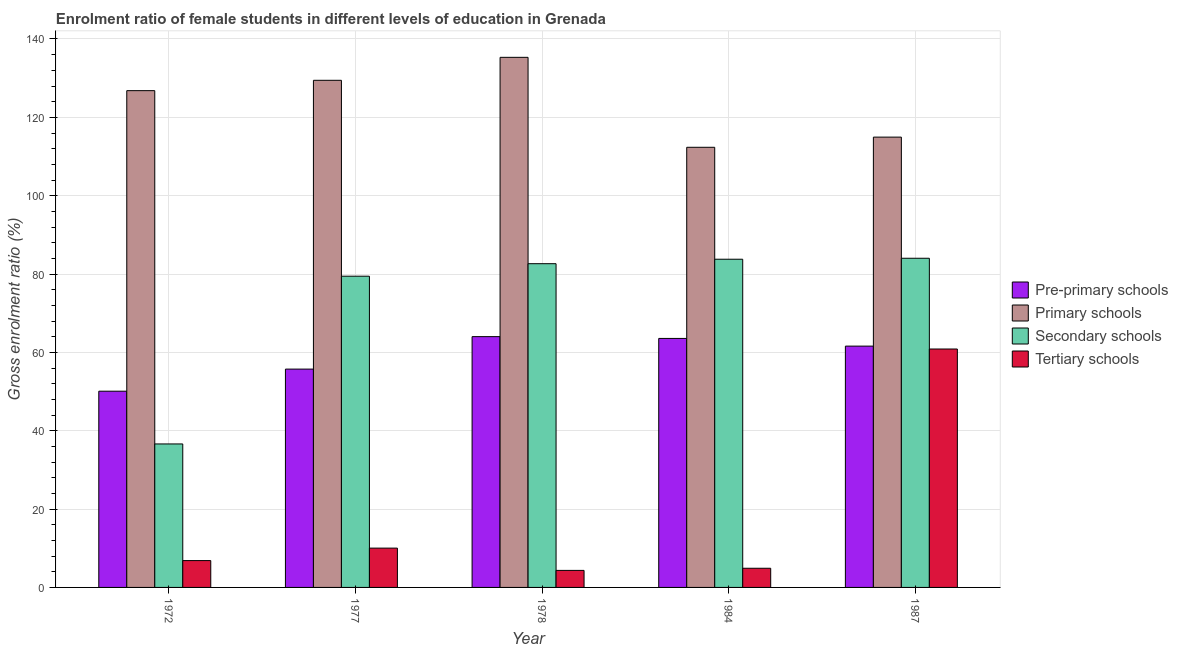Are the number of bars per tick equal to the number of legend labels?
Provide a short and direct response. Yes. Are the number of bars on each tick of the X-axis equal?
Ensure brevity in your answer.  Yes. In how many cases, is the number of bars for a given year not equal to the number of legend labels?
Offer a terse response. 0. What is the gross enrolment ratio(male) in pre-primary schools in 1972?
Provide a short and direct response. 50.09. Across all years, what is the maximum gross enrolment ratio(male) in pre-primary schools?
Provide a succinct answer. 64.02. Across all years, what is the minimum gross enrolment ratio(male) in secondary schools?
Your answer should be very brief. 36.63. In which year was the gross enrolment ratio(male) in primary schools minimum?
Offer a very short reply. 1984. What is the total gross enrolment ratio(male) in tertiary schools in the graph?
Make the answer very short. 86.99. What is the difference between the gross enrolment ratio(male) in primary schools in 1977 and that in 1987?
Give a very brief answer. 14.5. What is the difference between the gross enrolment ratio(male) in primary schools in 1978 and the gross enrolment ratio(male) in tertiary schools in 1984?
Provide a succinct answer. 22.96. What is the average gross enrolment ratio(male) in pre-primary schools per year?
Your answer should be very brief. 59. In the year 1987, what is the difference between the gross enrolment ratio(male) in pre-primary schools and gross enrolment ratio(male) in primary schools?
Offer a very short reply. 0. What is the ratio of the gross enrolment ratio(male) in pre-primary schools in 1978 to that in 1987?
Provide a short and direct response. 1.04. Is the gross enrolment ratio(male) in primary schools in 1977 less than that in 1987?
Ensure brevity in your answer.  No. Is the difference between the gross enrolment ratio(male) in tertiary schools in 1984 and 1987 greater than the difference between the gross enrolment ratio(male) in pre-primary schools in 1984 and 1987?
Ensure brevity in your answer.  No. What is the difference between the highest and the second highest gross enrolment ratio(male) in pre-primary schools?
Your answer should be very brief. 0.46. What is the difference between the highest and the lowest gross enrolment ratio(male) in tertiary schools?
Your answer should be very brief. 56.52. Is it the case that in every year, the sum of the gross enrolment ratio(male) in tertiary schools and gross enrolment ratio(male) in secondary schools is greater than the sum of gross enrolment ratio(male) in primary schools and gross enrolment ratio(male) in pre-primary schools?
Keep it short and to the point. No. What does the 4th bar from the left in 1987 represents?
Offer a very short reply. Tertiary schools. What does the 2nd bar from the right in 1984 represents?
Make the answer very short. Secondary schools. How many years are there in the graph?
Your response must be concise. 5. Does the graph contain grids?
Offer a very short reply. Yes. What is the title of the graph?
Ensure brevity in your answer.  Enrolment ratio of female students in different levels of education in Grenada. What is the Gross enrolment ratio (%) of Pre-primary schools in 1972?
Keep it short and to the point. 50.09. What is the Gross enrolment ratio (%) in Primary schools in 1972?
Provide a succinct answer. 126.81. What is the Gross enrolment ratio (%) in Secondary schools in 1972?
Your answer should be very brief. 36.63. What is the Gross enrolment ratio (%) in Tertiary schools in 1972?
Provide a succinct answer. 6.85. What is the Gross enrolment ratio (%) in Pre-primary schools in 1977?
Make the answer very short. 55.73. What is the Gross enrolment ratio (%) of Primary schools in 1977?
Your response must be concise. 129.45. What is the Gross enrolment ratio (%) of Secondary schools in 1977?
Provide a succinct answer. 79.45. What is the Gross enrolment ratio (%) of Tertiary schools in 1977?
Keep it short and to the point. 10.03. What is the Gross enrolment ratio (%) of Pre-primary schools in 1978?
Your answer should be compact. 64.02. What is the Gross enrolment ratio (%) of Primary schools in 1978?
Give a very brief answer. 135.32. What is the Gross enrolment ratio (%) in Secondary schools in 1978?
Offer a terse response. 82.64. What is the Gross enrolment ratio (%) of Tertiary schools in 1978?
Provide a short and direct response. 4.35. What is the Gross enrolment ratio (%) of Pre-primary schools in 1984?
Give a very brief answer. 63.56. What is the Gross enrolment ratio (%) in Primary schools in 1984?
Your response must be concise. 112.36. What is the Gross enrolment ratio (%) of Secondary schools in 1984?
Make the answer very short. 83.78. What is the Gross enrolment ratio (%) of Tertiary schools in 1984?
Offer a very short reply. 4.89. What is the Gross enrolment ratio (%) in Pre-primary schools in 1987?
Offer a terse response. 61.6. What is the Gross enrolment ratio (%) of Primary schools in 1987?
Offer a very short reply. 114.95. What is the Gross enrolment ratio (%) of Secondary schools in 1987?
Offer a terse response. 84.03. What is the Gross enrolment ratio (%) of Tertiary schools in 1987?
Ensure brevity in your answer.  60.86. Across all years, what is the maximum Gross enrolment ratio (%) in Pre-primary schools?
Offer a terse response. 64.02. Across all years, what is the maximum Gross enrolment ratio (%) of Primary schools?
Your answer should be very brief. 135.32. Across all years, what is the maximum Gross enrolment ratio (%) of Secondary schools?
Make the answer very short. 84.03. Across all years, what is the maximum Gross enrolment ratio (%) of Tertiary schools?
Provide a succinct answer. 60.86. Across all years, what is the minimum Gross enrolment ratio (%) in Pre-primary schools?
Your answer should be compact. 50.09. Across all years, what is the minimum Gross enrolment ratio (%) in Primary schools?
Offer a very short reply. 112.36. Across all years, what is the minimum Gross enrolment ratio (%) in Secondary schools?
Make the answer very short. 36.63. Across all years, what is the minimum Gross enrolment ratio (%) in Tertiary schools?
Your answer should be compact. 4.35. What is the total Gross enrolment ratio (%) in Pre-primary schools in the graph?
Your answer should be compact. 295.01. What is the total Gross enrolment ratio (%) in Primary schools in the graph?
Offer a terse response. 618.9. What is the total Gross enrolment ratio (%) in Secondary schools in the graph?
Give a very brief answer. 366.52. What is the total Gross enrolment ratio (%) of Tertiary schools in the graph?
Ensure brevity in your answer.  86.99. What is the difference between the Gross enrolment ratio (%) in Pre-primary schools in 1972 and that in 1977?
Your response must be concise. -5.64. What is the difference between the Gross enrolment ratio (%) in Primary schools in 1972 and that in 1977?
Offer a terse response. -2.64. What is the difference between the Gross enrolment ratio (%) in Secondary schools in 1972 and that in 1977?
Your answer should be very brief. -42.82. What is the difference between the Gross enrolment ratio (%) in Tertiary schools in 1972 and that in 1977?
Your answer should be very brief. -3.18. What is the difference between the Gross enrolment ratio (%) in Pre-primary schools in 1972 and that in 1978?
Your response must be concise. -13.93. What is the difference between the Gross enrolment ratio (%) of Primary schools in 1972 and that in 1978?
Offer a terse response. -8.51. What is the difference between the Gross enrolment ratio (%) in Secondary schools in 1972 and that in 1978?
Provide a short and direct response. -46.01. What is the difference between the Gross enrolment ratio (%) of Tertiary schools in 1972 and that in 1978?
Your answer should be very brief. 2.51. What is the difference between the Gross enrolment ratio (%) in Pre-primary schools in 1972 and that in 1984?
Your answer should be compact. -13.47. What is the difference between the Gross enrolment ratio (%) in Primary schools in 1972 and that in 1984?
Ensure brevity in your answer.  14.46. What is the difference between the Gross enrolment ratio (%) of Secondary schools in 1972 and that in 1984?
Make the answer very short. -47.15. What is the difference between the Gross enrolment ratio (%) in Tertiary schools in 1972 and that in 1984?
Your answer should be compact. 1.96. What is the difference between the Gross enrolment ratio (%) of Pre-primary schools in 1972 and that in 1987?
Provide a short and direct response. -11.51. What is the difference between the Gross enrolment ratio (%) of Primary schools in 1972 and that in 1987?
Your answer should be very brief. 11.86. What is the difference between the Gross enrolment ratio (%) in Secondary schools in 1972 and that in 1987?
Your answer should be very brief. -47.4. What is the difference between the Gross enrolment ratio (%) in Tertiary schools in 1972 and that in 1987?
Your response must be concise. -54.01. What is the difference between the Gross enrolment ratio (%) of Pre-primary schools in 1977 and that in 1978?
Your response must be concise. -8.29. What is the difference between the Gross enrolment ratio (%) of Primary schools in 1977 and that in 1978?
Your response must be concise. -5.87. What is the difference between the Gross enrolment ratio (%) of Secondary schools in 1977 and that in 1978?
Make the answer very short. -3.19. What is the difference between the Gross enrolment ratio (%) of Tertiary schools in 1977 and that in 1978?
Ensure brevity in your answer.  5.69. What is the difference between the Gross enrolment ratio (%) of Pre-primary schools in 1977 and that in 1984?
Your answer should be very brief. -7.83. What is the difference between the Gross enrolment ratio (%) in Primary schools in 1977 and that in 1984?
Offer a terse response. 17.1. What is the difference between the Gross enrolment ratio (%) of Secondary schools in 1977 and that in 1984?
Give a very brief answer. -4.33. What is the difference between the Gross enrolment ratio (%) in Tertiary schools in 1977 and that in 1984?
Your response must be concise. 5.14. What is the difference between the Gross enrolment ratio (%) in Pre-primary schools in 1977 and that in 1987?
Keep it short and to the point. -5.87. What is the difference between the Gross enrolment ratio (%) of Primary schools in 1977 and that in 1987?
Keep it short and to the point. 14.5. What is the difference between the Gross enrolment ratio (%) in Secondary schools in 1977 and that in 1987?
Offer a terse response. -4.58. What is the difference between the Gross enrolment ratio (%) in Tertiary schools in 1977 and that in 1987?
Make the answer very short. -50.83. What is the difference between the Gross enrolment ratio (%) of Pre-primary schools in 1978 and that in 1984?
Provide a succinct answer. 0.46. What is the difference between the Gross enrolment ratio (%) of Primary schools in 1978 and that in 1984?
Make the answer very short. 22.96. What is the difference between the Gross enrolment ratio (%) in Secondary schools in 1978 and that in 1984?
Provide a short and direct response. -1.14. What is the difference between the Gross enrolment ratio (%) of Tertiary schools in 1978 and that in 1984?
Provide a succinct answer. -0.55. What is the difference between the Gross enrolment ratio (%) in Pre-primary schools in 1978 and that in 1987?
Offer a very short reply. 2.42. What is the difference between the Gross enrolment ratio (%) of Primary schools in 1978 and that in 1987?
Ensure brevity in your answer.  20.37. What is the difference between the Gross enrolment ratio (%) of Secondary schools in 1978 and that in 1987?
Your response must be concise. -1.39. What is the difference between the Gross enrolment ratio (%) of Tertiary schools in 1978 and that in 1987?
Ensure brevity in your answer.  -56.52. What is the difference between the Gross enrolment ratio (%) in Pre-primary schools in 1984 and that in 1987?
Give a very brief answer. 1.96. What is the difference between the Gross enrolment ratio (%) in Primary schools in 1984 and that in 1987?
Offer a terse response. -2.6. What is the difference between the Gross enrolment ratio (%) in Secondary schools in 1984 and that in 1987?
Offer a terse response. -0.25. What is the difference between the Gross enrolment ratio (%) of Tertiary schools in 1984 and that in 1987?
Ensure brevity in your answer.  -55.97. What is the difference between the Gross enrolment ratio (%) of Pre-primary schools in 1972 and the Gross enrolment ratio (%) of Primary schools in 1977?
Make the answer very short. -79.36. What is the difference between the Gross enrolment ratio (%) in Pre-primary schools in 1972 and the Gross enrolment ratio (%) in Secondary schools in 1977?
Offer a very short reply. -29.35. What is the difference between the Gross enrolment ratio (%) in Pre-primary schools in 1972 and the Gross enrolment ratio (%) in Tertiary schools in 1977?
Ensure brevity in your answer.  40.06. What is the difference between the Gross enrolment ratio (%) of Primary schools in 1972 and the Gross enrolment ratio (%) of Secondary schools in 1977?
Your answer should be compact. 47.36. What is the difference between the Gross enrolment ratio (%) of Primary schools in 1972 and the Gross enrolment ratio (%) of Tertiary schools in 1977?
Your answer should be very brief. 116.78. What is the difference between the Gross enrolment ratio (%) in Secondary schools in 1972 and the Gross enrolment ratio (%) in Tertiary schools in 1977?
Provide a succinct answer. 26.59. What is the difference between the Gross enrolment ratio (%) of Pre-primary schools in 1972 and the Gross enrolment ratio (%) of Primary schools in 1978?
Keep it short and to the point. -85.23. What is the difference between the Gross enrolment ratio (%) of Pre-primary schools in 1972 and the Gross enrolment ratio (%) of Secondary schools in 1978?
Provide a succinct answer. -32.54. What is the difference between the Gross enrolment ratio (%) in Pre-primary schools in 1972 and the Gross enrolment ratio (%) in Tertiary schools in 1978?
Ensure brevity in your answer.  45.75. What is the difference between the Gross enrolment ratio (%) in Primary schools in 1972 and the Gross enrolment ratio (%) in Secondary schools in 1978?
Offer a very short reply. 44.17. What is the difference between the Gross enrolment ratio (%) of Primary schools in 1972 and the Gross enrolment ratio (%) of Tertiary schools in 1978?
Ensure brevity in your answer.  122.47. What is the difference between the Gross enrolment ratio (%) of Secondary schools in 1972 and the Gross enrolment ratio (%) of Tertiary schools in 1978?
Provide a short and direct response. 32.28. What is the difference between the Gross enrolment ratio (%) in Pre-primary schools in 1972 and the Gross enrolment ratio (%) in Primary schools in 1984?
Offer a very short reply. -62.26. What is the difference between the Gross enrolment ratio (%) in Pre-primary schools in 1972 and the Gross enrolment ratio (%) in Secondary schools in 1984?
Your answer should be compact. -33.69. What is the difference between the Gross enrolment ratio (%) of Pre-primary schools in 1972 and the Gross enrolment ratio (%) of Tertiary schools in 1984?
Keep it short and to the point. 45.2. What is the difference between the Gross enrolment ratio (%) in Primary schools in 1972 and the Gross enrolment ratio (%) in Secondary schools in 1984?
Offer a terse response. 43.03. What is the difference between the Gross enrolment ratio (%) of Primary schools in 1972 and the Gross enrolment ratio (%) of Tertiary schools in 1984?
Keep it short and to the point. 121.92. What is the difference between the Gross enrolment ratio (%) of Secondary schools in 1972 and the Gross enrolment ratio (%) of Tertiary schools in 1984?
Offer a very short reply. 31.73. What is the difference between the Gross enrolment ratio (%) in Pre-primary schools in 1972 and the Gross enrolment ratio (%) in Primary schools in 1987?
Your answer should be compact. -64.86. What is the difference between the Gross enrolment ratio (%) in Pre-primary schools in 1972 and the Gross enrolment ratio (%) in Secondary schools in 1987?
Your answer should be very brief. -33.93. What is the difference between the Gross enrolment ratio (%) of Pre-primary schools in 1972 and the Gross enrolment ratio (%) of Tertiary schools in 1987?
Your response must be concise. -10.77. What is the difference between the Gross enrolment ratio (%) of Primary schools in 1972 and the Gross enrolment ratio (%) of Secondary schools in 1987?
Your response must be concise. 42.79. What is the difference between the Gross enrolment ratio (%) of Primary schools in 1972 and the Gross enrolment ratio (%) of Tertiary schools in 1987?
Your response must be concise. 65.95. What is the difference between the Gross enrolment ratio (%) in Secondary schools in 1972 and the Gross enrolment ratio (%) in Tertiary schools in 1987?
Provide a short and direct response. -24.24. What is the difference between the Gross enrolment ratio (%) of Pre-primary schools in 1977 and the Gross enrolment ratio (%) of Primary schools in 1978?
Keep it short and to the point. -79.59. What is the difference between the Gross enrolment ratio (%) in Pre-primary schools in 1977 and the Gross enrolment ratio (%) in Secondary schools in 1978?
Keep it short and to the point. -26.91. What is the difference between the Gross enrolment ratio (%) of Pre-primary schools in 1977 and the Gross enrolment ratio (%) of Tertiary schools in 1978?
Offer a very short reply. 51.39. What is the difference between the Gross enrolment ratio (%) of Primary schools in 1977 and the Gross enrolment ratio (%) of Secondary schools in 1978?
Provide a short and direct response. 46.82. What is the difference between the Gross enrolment ratio (%) of Primary schools in 1977 and the Gross enrolment ratio (%) of Tertiary schools in 1978?
Keep it short and to the point. 125.11. What is the difference between the Gross enrolment ratio (%) in Secondary schools in 1977 and the Gross enrolment ratio (%) in Tertiary schools in 1978?
Your answer should be very brief. 75.1. What is the difference between the Gross enrolment ratio (%) in Pre-primary schools in 1977 and the Gross enrolment ratio (%) in Primary schools in 1984?
Provide a short and direct response. -56.62. What is the difference between the Gross enrolment ratio (%) of Pre-primary schools in 1977 and the Gross enrolment ratio (%) of Secondary schools in 1984?
Offer a terse response. -28.05. What is the difference between the Gross enrolment ratio (%) of Pre-primary schools in 1977 and the Gross enrolment ratio (%) of Tertiary schools in 1984?
Ensure brevity in your answer.  50.84. What is the difference between the Gross enrolment ratio (%) in Primary schools in 1977 and the Gross enrolment ratio (%) in Secondary schools in 1984?
Ensure brevity in your answer.  45.67. What is the difference between the Gross enrolment ratio (%) in Primary schools in 1977 and the Gross enrolment ratio (%) in Tertiary schools in 1984?
Ensure brevity in your answer.  124.56. What is the difference between the Gross enrolment ratio (%) in Secondary schools in 1977 and the Gross enrolment ratio (%) in Tertiary schools in 1984?
Your response must be concise. 74.55. What is the difference between the Gross enrolment ratio (%) of Pre-primary schools in 1977 and the Gross enrolment ratio (%) of Primary schools in 1987?
Make the answer very short. -59.22. What is the difference between the Gross enrolment ratio (%) in Pre-primary schools in 1977 and the Gross enrolment ratio (%) in Secondary schools in 1987?
Offer a terse response. -28.29. What is the difference between the Gross enrolment ratio (%) of Pre-primary schools in 1977 and the Gross enrolment ratio (%) of Tertiary schools in 1987?
Provide a short and direct response. -5.13. What is the difference between the Gross enrolment ratio (%) of Primary schools in 1977 and the Gross enrolment ratio (%) of Secondary schools in 1987?
Offer a terse response. 45.43. What is the difference between the Gross enrolment ratio (%) of Primary schools in 1977 and the Gross enrolment ratio (%) of Tertiary schools in 1987?
Ensure brevity in your answer.  68.59. What is the difference between the Gross enrolment ratio (%) in Secondary schools in 1977 and the Gross enrolment ratio (%) in Tertiary schools in 1987?
Offer a terse response. 18.58. What is the difference between the Gross enrolment ratio (%) in Pre-primary schools in 1978 and the Gross enrolment ratio (%) in Primary schools in 1984?
Provide a succinct answer. -48.34. What is the difference between the Gross enrolment ratio (%) in Pre-primary schools in 1978 and the Gross enrolment ratio (%) in Secondary schools in 1984?
Provide a succinct answer. -19.76. What is the difference between the Gross enrolment ratio (%) of Pre-primary schools in 1978 and the Gross enrolment ratio (%) of Tertiary schools in 1984?
Your response must be concise. 59.13. What is the difference between the Gross enrolment ratio (%) in Primary schools in 1978 and the Gross enrolment ratio (%) in Secondary schools in 1984?
Provide a succinct answer. 51.54. What is the difference between the Gross enrolment ratio (%) in Primary schools in 1978 and the Gross enrolment ratio (%) in Tertiary schools in 1984?
Make the answer very short. 130.43. What is the difference between the Gross enrolment ratio (%) of Secondary schools in 1978 and the Gross enrolment ratio (%) of Tertiary schools in 1984?
Your answer should be compact. 77.75. What is the difference between the Gross enrolment ratio (%) of Pre-primary schools in 1978 and the Gross enrolment ratio (%) of Primary schools in 1987?
Provide a succinct answer. -50.93. What is the difference between the Gross enrolment ratio (%) of Pre-primary schools in 1978 and the Gross enrolment ratio (%) of Secondary schools in 1987?
Keep it short and to the point. -20.01. What is the difference between the Gross enrolment ratio (%) in Pre-primary schools in 1978 and the Gross enrolment ratio (%) in Tertiary schools in 1987?
Provide a short and direct response. 3.16. What is the difference between the Gross enrolment ratio (%) of Primary schools in 1978 and the Gross enrolment ratio (%) of Secondary schools in 1987?
Make the answer very short. 51.29. What is the difference between the Gross enrolment ratio (%) of Primary schools in 1978 and the Gross enrolment ratio (%) of Tertiary schools in 1987?
Your response must be concise. 74.46. What is the difference between the Gross enrolment ratio (%) in Secondary schools in 1978 and the Gross enrolment ratio (%) in Tertiary schools in 1987?
Your response must be concise. 21.77. What is the difference between the Gross enrolment ratio (%) in Pre-primary schools in 1984 and the Gross enrolment ratio (%) in Primary schools in 1987?
Your response must be concise. -51.39. What is the difference between the Gross enrolment ratio (%) of Pre-primary schools in 1984 and the Gross enrolment ratio (%) of Secondary schools in 1987?
Give a very brief answer. -20.46. What is the difference between the Gross enrolment ratio (%) in Pre-primary schools in 1984 and the Gross enrolment ratio (%) in Tertiary schools in 1987?
Provide a succinct answer. 2.7. What is the difference between the Gross enrolment ratio (%) in Primary schools in 1984 and the Gross enrolment ratio (%) in Secondary schools in 1987?
Your answer should be very brief. 28.33. What is the difference between the Gross enrolment ratio (%) in Primary schools in 1984 and the Gross enrolment ratio (%) in Tertiary schools in 1987?
Ensure brevity in your answer.  51.49. What is the difference between the Gross enrolment ratio (%) in Secondary schools in 1984 and the Gross enrolment ratio (%) in Tertiary schools in 1987?
Your response must be concise. 22.92. What is the average Gross enrolment ratio (%) in Pre-primary schools per year?
Give a very brief answer. 59. What is the average Gross enrolment ratio (%) in Primary schools per year?
Provide a short and direct response. 123.78. What is the average Gross enrolment ratio (%) of Secondary schools per year?
Your response must be concise. 73.3. What is the average Gross enrolment ratio (%) of Tertiary schools per year?
Keep it short and to the point. 17.4. In the year 1972, what is the difference between the Gross enrolment ratio (%) in Pre-primary schools and Gross enrolment ratio (%) in Primary schools?
Your answer should be compact. -76.72. In the year 1972, what is the difference between the Gross enrolment ratio (%) of Pre-primary schools and Gross enrolment ratio (%) of Secondary schools?
Your response must be concise. 13.47. In the year 1972, what is the difference between the Gross enrolment ratio (%) in Pre-primary schools and Gross enrolment ratio (%) in Tertiary schools?
Make the answer very short. 43.24. In the year 1972, what is the difference between the Gross enrolment ratio (%) in Primary schools and Gross enrolment ratio (%) in Secondary schools?
Provide a succinct answer. 90.19. In the year 1972, what is the difference between the Gross enrolment ratio (%) in Primary schools and Gross enrolment ratio (%) in Tertiary schools?
Your answer should be compact. 119.96. In the year 1972, what is the difference between the Gross enrolment ratio (%) of Secondary schools and Gross enrolment ratio (%) of Tertiary schools?
Provide a short and direct response. 29.77. In the year 1977, what is the difference between the Gross enrolment ratio (%) of Pre-primary schools and Gross enrolment ratio (%) of Primary schools?
Give a very brief answer. -73.72. In the year 1977, what is the difference between the Gross enrolment ratio (%) of Pre-primary schools and Gross enrolment ratio (%) of Secondary schools?
Your response must be concise. -23.72. In the year 1977, what is the difference between the Gross enrolment ratio (%) of Pre-primary schools and Gross enrolment ratio (%) of Tertiary schools?
Keep it short and to the point. 45.7. In the year 1977, what is the difference between the Gross enrolment ratio (%) of Primary schools and Gross enrolment ratio (%) of Secondary schools?
Your answer should be very brief. 50.01. In the year 1977, what is the difference between the Gross enrolment ratio (%) of Primary schools and Gross enrolment ratio (%) of Tertiary schools?
Offer a very short reply. 119.42. In the year 1977, what is the difference between the Gross enrolment ratio (%) of Secondary schools and Gross enrolment ratio (%) of Tertiary schools?
Keep it short and to the point. 69.41. In the year 1978, what is the difference between the Gross enrolment ratio (%) in Pre-primary schools and Gross enrolment ratio (%) in Primary schools?
Offer a terse response. -71.3. In the year 1978, what is the difference between the Gross enrolment ratio (%) of Pre-primary schools and Gross enrolment ratio (%) of Secondary schools?
Your answer should be very brief. -18.62. In the year 1978, what is the difference between the Gross enrolment ratio (%) in Pre-primary schools and Gross enrolment ratio (%) in Tertiary schools?
Keep it short and to the point. 59.67. In the year 1978, what is the difference between the Gross enrolment ratio (%) of Primary schools and Gross enrolment ratio (%) of Secondary schools?
Your response must be concise. 52.68. In the year 1978, what is the difference between the Gross enrolment ratio (%) of Primary schools and Gross enrolment ratio (%) of Tertiary schools?
Provide a short and direct response. 130.97. In the year 1978, what is the difference between the Gross enrolment ratio (%) in Secondary schools and Gross enrolment ratio (%) in Tertiary schools?
Provide a succinct answer. 78.29. In the year 1984, what is the difference between the Gross enrolment ratio (%) in Pre-primary schools and Gross enrolment ratio (%) in Primary schools?
Make the answer very short. -48.79. In the year 1984, what is the difference between the Gross enrolment ratio (%) of Pre-primary schools and Gross enrolment ratio (%) of Secondary schools?
Offer a terse response. -20.22. In the year 1984, what is the difference between the Gross enrolment ratio (%) in Pre-primary schools and Gross enrolment ratio (%) in Tertiary schools?
Make the answer very short. 58.67. In the year 1984, what is the difference between the Gross enrolment ratio (%) in Primary schools and Gross enrolment ratio (%) in Secondary schools?
Your answer should be compact. 28.57. In the year 1984, what is the difference between the Gross enrolment ratio (%) in Primary schools and Gross enrolment ratio (%) in Tertiary schools?
Ensure brevity in your answer.  107.46. In the year 1984, what is the difference between the Gross enrolment ratio (%) of Secondary schools and Gross enrolment ratio (%) of Tertiary schools?
Your response must be concise. 78.89. In the year 1987, what is the difference between the Gross enrolment ratio (%) in Pre-primary schools and Gross enrolment ratio (%) in Primary schools?
Offer a very short reply. -53.35. In the year 1987, what is the difference between the Gross enrolment ratio (%) in Pre-primary schools and Gross enrolment ratio (%) in Secondary schools?
Keep it short and to the point. -22.43. In the year 1987, what is the difference between the Gross enrolment ratio (%) in Pre-primary schools and Gross enrolment ratio (%) in Tertiary schools?
Ensure brevity in your answer.  0.74. In the year 1987, what is the difference between the Gross enrolment ratio (%) in Primary schools and Gross enrolment ratio (%) in Secondary schools?
Make the answer very short. 30.93. In the year 1987, what is the difference between the Gross enrolment ratio (%) of Primary schools and Gross enrolment ratio (%) of Tertiary schools?
Keep it short and to the point. 54.09. In the year 1987, what is the difference between the Gross enrolment ratio (%) in Secondary schools and Gross enrolment ratio (%) in Tertiary schools?
Provide a succinct answer. 23.16. What is the ratio of the Gross enrolment ratio (%) of Pre-primary schools in 1972 to that in 1977?
Provide a short and direct response. 0.9. What is the ratio of the Gross enrolment ratio (%) in Primary schools in 1972 to that in 1977?
Give a very brief answer. 0.98. What is the ratio of the Gross enrolment ratio (%) in Secondary schools in 1972 to that in 1977?
Your answer should be compact. 0.46. What is the ratio of the Gross enrolment ratio (%) in Tertiary schools in 1972 to that in 1977?
Keep it short and to the point. 0.68. What is the ratio of the Gross enrolment ratio (%) of Pre-primary schools in 1972 to that in 1978?
Make the answer very short. 0.78. What is the ratio of the Gross enrolment ratio (%) in Primary schools in 1972 to that in 1978?
Ensure brevity in your answer.  0.94. What is the ratio of the Gross enrolment ratio (%) of Secondary schools in 1972 to that in 1978?
Provide a succinct answer. 0.44. What is the ratio of the Gross enrolment ratio (%) of Tertiary schools in 1972 to that in 1978?
Make the answer very short. 1.58. What is the ratio of the Gross enrolment ratio (%) of Pre-primary schools in 1972 to that in 1984?
Provide a succinct answer. 0.79. What is the ratio of the Gross enrolment ratio (%) of Primary schools in 1972 to that in 1984?
Ensure brevity in your answer.  1.13. What is the ratio of the Gross enrolment ratio (%) in Secondary schools in 1972 to that in 1984?
Offer a terse response. 0.44. What is the ratio of the Gross enrolment ratio (%) in Tertiary schools in 1972 to that in 1984?
Give a very brief answer. 1.4. What is the ratio of the Gross enrolment ratio (%) in Pre-primary schools in 1972 to that in 1987?
Provide a succinct answer. 0.81. What is the ratio of the Gross enrolment ratio (%) in Primary schools in 1972 to that in 1987?
Make the answer very short. 1.1. What is the ratio of the Gross enrolment ratio (%) of Secondary schools in 1972 to that in 1987?
Your answer should be compact. 0.44. What is the ratio of the Gross enrolment ratio (%) of Tertiary schools in 1972 to that in 1987?
Your answer should be very brief. 0.11. What is the ratio of the Gross enrolment ratio (%) in Pre-primary schools in 1977 to that in 1978?
Your response must be concise. 0.87. What is the ratio of the Gross enrolment ratio (%) in Primary schools in 1977 to that in 1978?
Offer a terse response. 0.96. What is the ratio of the Gross enrolment ratio (%) of Secondary schools in 1977 to that in 1978?
Give a very brief answer. 0.96. What is the ratio of the Gross enrolment ratio (%) of Tertiary schools in 1977 to that in 1978?
Keep it short and to the point. 2.31. What is the ratio of the Gross enrolment ratio (%) of Pre-primary schools in 1977 to that in 1984?
Provide a succinct answer. 0.88. What is the ratio of the Gross enrolment ratio (%) of Primary schools in 1977 to that in 1984?
Make the answer very short. 1.15. What is the ratio of the Gross enrolment ratio (%) in Secondary schools in 1977 to that in 1984?
Offer a terse response. 0.95. What is the ratio of the Gross enrolment ratio (%) of Tertiary schools in 1977 to that in 1984?
Offer a terse response. 2.05. What is the ratio of the Gross enrolment ratio (%) of Pre-primary schools in 1977 to that in 1987?
Provide a succinct answer. 0.9. What is the ratio of the Gross enrolment ratio (%) of Primary schools in 1977 to that in 1987?
Give a very brief answer. 1.13. What is the ratio of the Gross enrolment ratio (%) in Secondary schools in 1977 to that in 1987?
Your answer should be compact. 0.95. What is the ratio of the Gross enrolment ratio (%) of Tertiary schools in 1977 to that in 1987?
Provide a succinct answer. 0.16. What is the ratio of the Gross enrolment ratio (%) in Pre-primary schools in 1978 to that in 1984?
Keep it short and to the point. 1.01. What is the ratio of the Gross enrolment ratio (%) of Primary schools in 1978 to that in 1984?
Provide a short and direct response. 1.2. What is the ratio of the Gross enrolment ratio (%) in Secondary schools in 1978 to that in 1984?
Provide a short and direct response. 0.99. What is the ratio of the Gross enrolment ratio (%) in Tertiary schools in 1978 to that in 1984?
Provide a short and direct response. 0.89. What is the ratio of the Gross enrolment ratio (%) in Pre-primary schools in 1978 to that in 1987?
Offer a terse response. 1.04. What is the ratio of the Gross enrolment ratio (%) in Primary schools in 1978 to that in 1987?
Make the answer very short. 1.18. What is the ratio of the Gross enrolment ratio (%) in Secondary schools in 1978 to that in 1987?
Your answer should be compact. 0.98. What is the ratio of the Gross enrolment ratio (%) of Tertiary schools in 1978 to that in 1987?
Provide a short and direct response. 0.07. What is the ratio of the Gross enrolment ratio (%) in Pre-primary schools in 1984 to that in 1987?
Provide a succinct answer. 1.03. What is the ratio of the Gross enrolment ratio (%) in Primary schools in 1984 to that in 1987?
Provide a short and direct response. 0.98. What is the ratio of the Gross enrolment ratio (%) in Secondary schools in 1984 to that in 1987?
Your answer should be compact. 1. What is the ratio of the Gross enrolment ratio (%) in Tertiary schools in 1984 to that in 1987?
Offer a terse response. 0.08. What is the difference between the highest and the second highest Gross enrolment ratio (%) of Pre-primary schools?
Offer a terse response. 0.46. What is the difference between the highest and the second highest Gross enrolment ratio (%) of Primary schools?
Give a very brief answer. 5.87. What is the difference between the highest and the second highest Gross enrolment ratio (%) of Secondary schools?
Offer a terse response. 0.25. What is the difference between the highest and the second highest Gross enrolment ratio (%) in Tertiary schools?
Keep it short and to the point. 50.83. What is the difference between the highest and the lowest Gross enrolment ratio (%) of Pre-primary schools?
Keep it short and to the point. 13.93. What is the difference between the highest and the lowest Gross enrolment ratio (%) in Primary schools?
Keep it short and to the point. 22.96. What is the difference between the highest and the lowest Gross enrolment ratio (%) of Secondary schools?
Keep it short and to the point. 47.4. What is the difference between the highest and the lowest Gross enrolment ratio (%) in Tertiary schools?
Offer a very short reply. 56.52. 